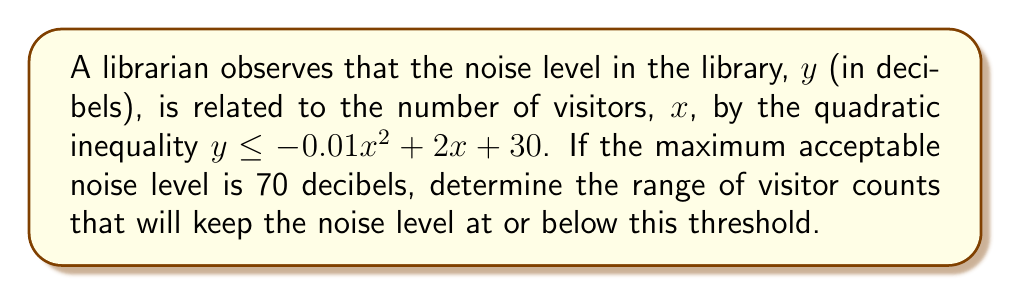Help me with this question. 1) We start with the given quadratic inequality:
   $y \leq -0.01x^2 + 2x + 30$

2) The maximum acceptable noise level is 70 decibels, so we set $y = 70$:
   $70 \leq -0.01x^2 + 2x + 30$

3) Rearrange the inequality:
   $-0.01x^2 + 2x - 40 \geq 0$

4) Multiply all terms by -100 to make the coefficient of $x^2$ positive, and flip the inequality sign:
   $x^2 - 200x + 4000 \leq 0$

5) This is a quadratic inequality. To solve it, we need to find the roots of the quadratic equation:
   $x^2 - 200x + 4000 = 0$

6) Use the quadratic formula: $x = \frac{-b \pm \sqrt{b^2 - 4ac}}{2a}$
   Here, $a=1$, $b=-200$, and $c=4000$

7) Calculating:
   $x = \frac{200 \pm \sqrt{40000 - 16000}}{2} = \frac{200 \pm \sqrt{24000}}{2} = \frac{200 \pm 20\sqrt{60}}{2}$

8) Simplify:
   $x = 100 \pm 10\sqrt{60}$

9) Therefore, the solutions are:
   $x_1 = 100 - 10\sqrt{60} \approx 22.6$ and $x_2 = 100 + 10\sqrt{60} \approx 177.4$

10) For a quadratic inequality of the form $ax^2 + bx + c \leq 0$ where $a > 0$, the solution is the interval between the roots.

Therefore, the range of visitor counts that will keep the noise level at or below 70 decibels is approximately 23 to 177 visitors (rounding to the nearest whole number, as we can't have fractional visitors).
Answer: $[23, 177]$ visitors 